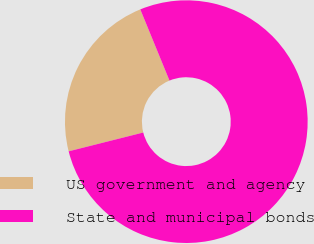<chart> <loc_0><loc_0><loc_500><loc_500><pie_chart><fcel>US government and agency<fcel>State and municipal bonds<nl><fcel>22.74%<fcel>77.26%<nl></chart> 